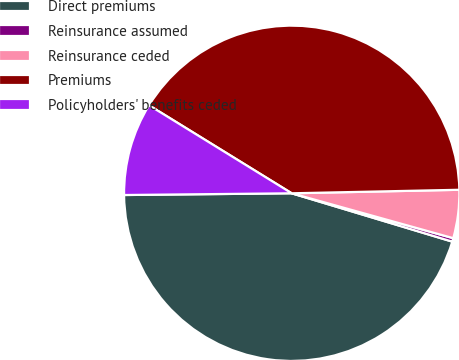<chart> <loc_0><loc_0><loc_500><loc_500><pie_chart><fcel>Direct premiums<fcel>Reinsurance assumed<fcel>Reinsurance ceded<fcel>Premiums<fcel>Policyholders' benefits ceded<nl><fcel>45.18%<fcel>0.34%<fcel>4.65%<fcel>40.87%<fcel>8.96%<nl></chart> 